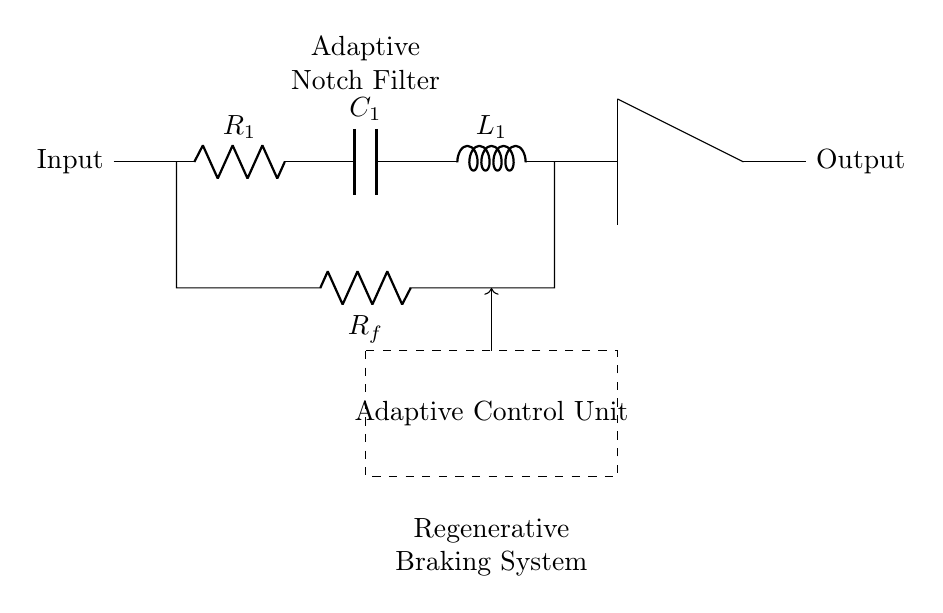What type of filter is represented in this circuit? The circuit diagram explicitly labels the component as an "Adaptive Notch Filter," which is also prominently positioned within the diagram. This indicates the function of the circuit as it relates to filtering out specific frequency noise.
Answer: Adaptive Notch Filter How many resistors are present in the circuit? By examining the circuit diagram, we see there are two resistors: R1 and Rf. They are clearly labeled and positioned within the circuit, making it easy to count them.
Answer: Two What role does the operational amplifier serve in the circuit? The operational amplifier is shown in the circuit and is often used to amplify the output signal or improve the impedance characteristics in filtering circuits. It is indicated to be connected to the feedback loop, directly influencing the filter's performance by adjusting the gain based on specific conditions.
Answer: Amplification What is the purpose of the adaptive control unit in this circuit? The adaptive control unit is responsible for adjusting the filter parameters automatically based on the noise conditions in the regenerative braking system. This enables it to effectively adapt to varying noise frequencies, enhancing the system's efficiency and reliability in reducing unwanted signals.
Answer: Parameter Adjustment What is connected in series with the inductor in this circuit? By analyzing the structure of the circuit, we notice that the inductor is connected in series with a capacitor, which implies a relationship between energy storage and filtering characteristics within the circuit.
Answer: Capacitor Which component is used for feedback in the filter? The feedback in the filter is provided by the resistor labeled Rf. It connects from the output of the operational amplifier back to the input, creating a feedback loop that is essential for the adaptive functionality of this filter.
Answer: Resistor F What does the dashed rectangle signify in the circuit? The dashed rectangle denotes the location of the adaptive control unit, indicating that this section contains circuitry or components involved in the adaptive feature of the notch filter, which tailor the filter's performance dynamically.
Answer: Adaptive Control Unit 